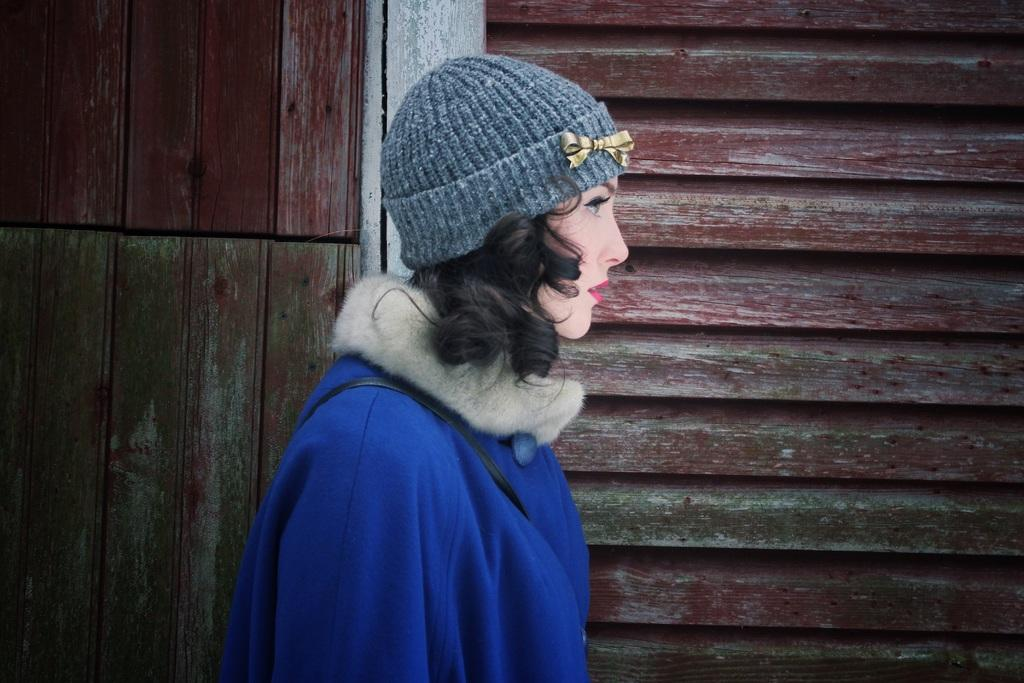Who is present in the image? There is a woman in the image. What is the woman wearing on her upper body? The woman is wearing a blue jacket. What type of headwear is the woman wearing? The woman is wearing a gray cap. What can be seen in the background of the image? There is a wooden wall in the image. What type of machine is hanging from the branch in the image? There is no machine or branch present in the image. 